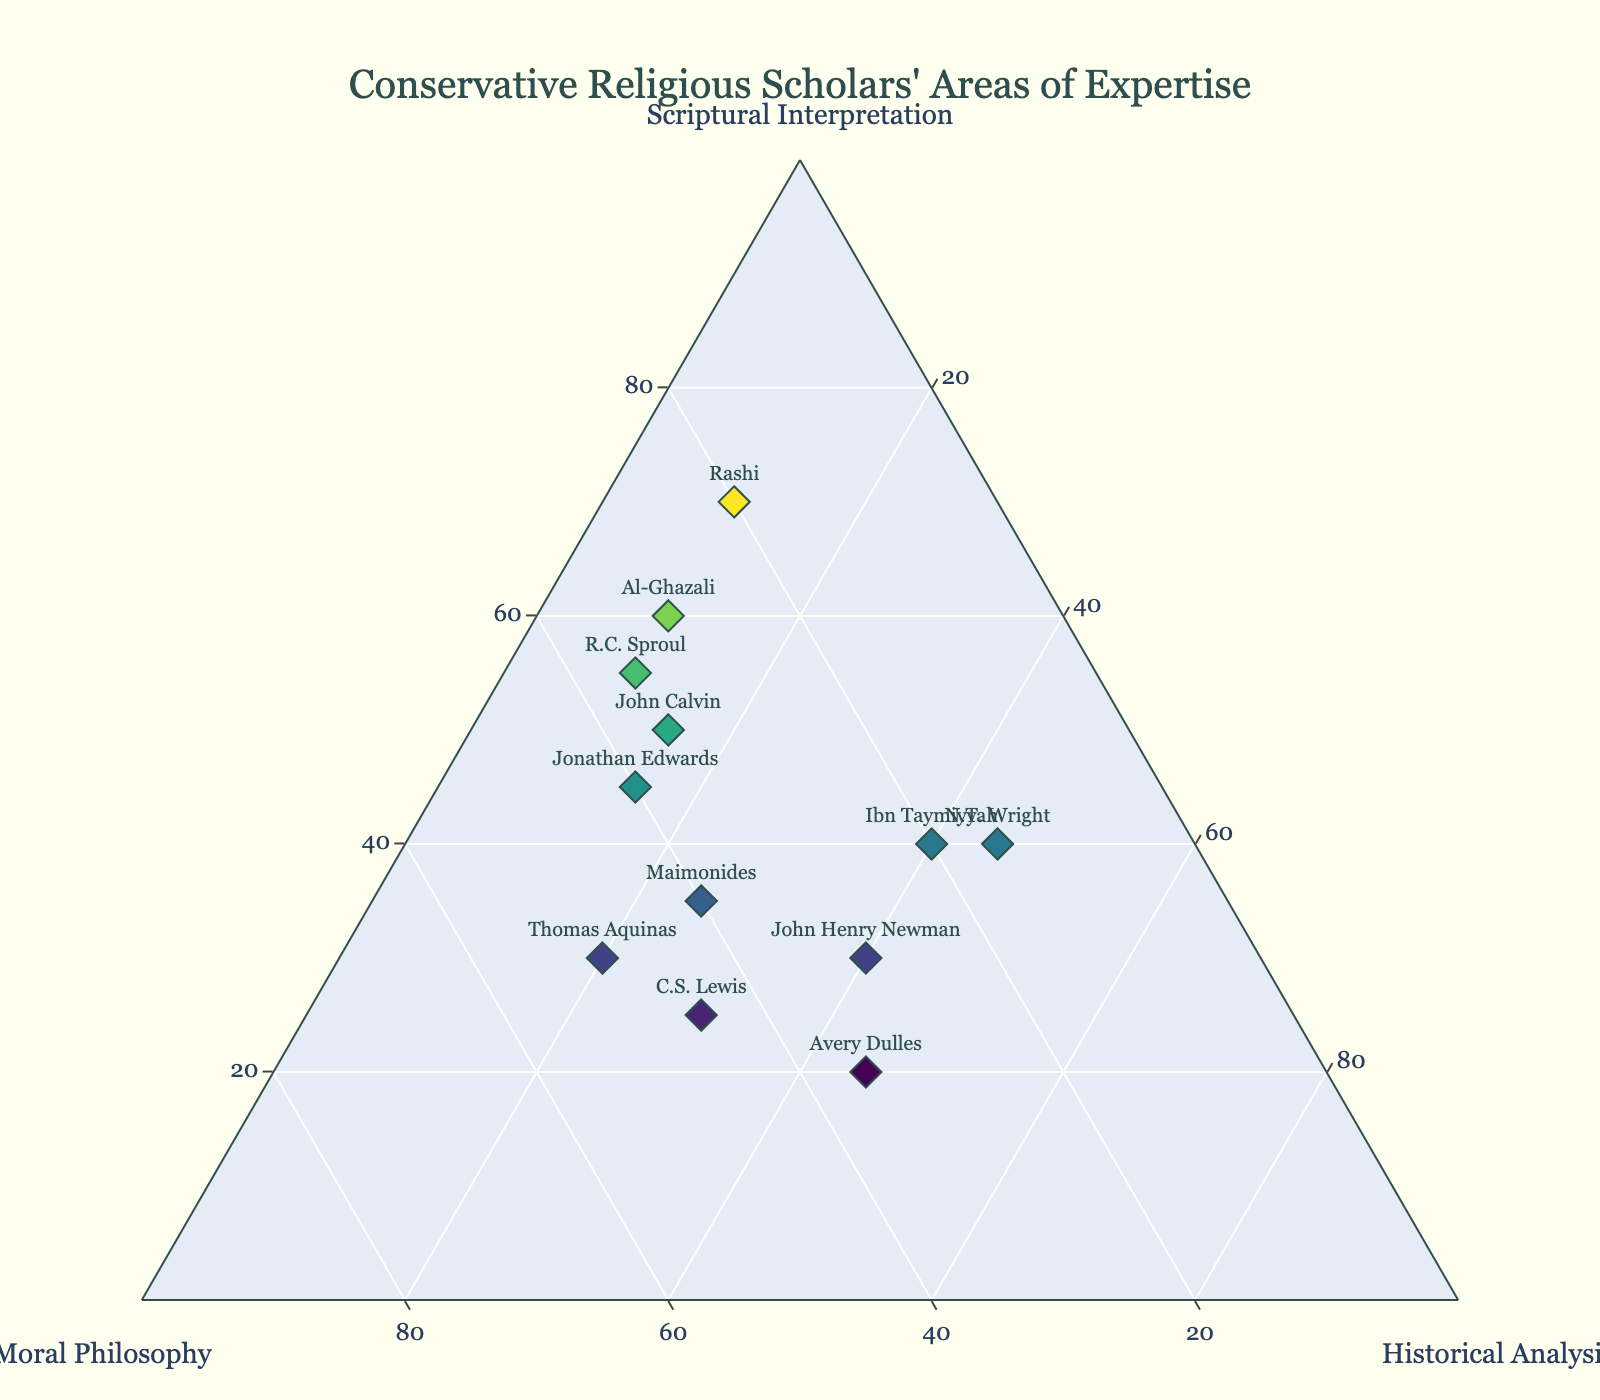What is the title of the ternary plot? The title of the ternary plot is placed at the top and usually describes the main subject visualized in the figure. Here, it particularly points out the theme of interest.
Answer: Conservative Religious Scholars' Areas of Expertise How many scholars are displayed in the ternary plot? Each scholar is represented by a single mark on the plot. Counting these marks will give the total number of scholars.
Answer: 12 Which scholar has the highest emphasis on Scriptural Interpretation? By looking at the axis labeled "Scriptural Interpretation," you can find the scholar whose marker is closest to this axis's apex. The percentage listed at this apex for the scholar can also be cross-referenced in the data.
Answer: Rashi Which scholars have an exactly equal focus on Scriptural Interpretation and Moral Philosophy? Look for markers whose values on Scriptural Interpretation and Moral Philosophy are the same or very close. The percentage values on the plot can identify this relationship.
Answer: John Henry Newman What is the combined focus on Historical Analysis for Thomas Aquinas and N.T. Wright? Sum up the percentages of Historical Analysis for both scholars using the data dictionary. Thomas Aquinas has 20%, and N.T. Wright has 45%. Thus, 20 + 45 = 65.
Answer: 65% Who has the lowest focus on Historical Analysis, and what is their emphasis on Scriptural Interpretation? Find the scholar with the smallest percentage in Historical Analysis and then locate their corresponding focus on Scriptural Interpretation. Avery Dulles has 45% Historical Analysis, but John Henry Newman has 40%. Both have a Scriptural Interpretation value respectively.
Answer: Rashi, 70% Which scholar exhibits the most balanced focus between all three areas of expertise? Find the scholar whose markers are approximately equidistant from the three apexes of the ternary plot, suggesting an equal distribution among Scriptural Interpretation, Moral Philosophy, and Historical Analysis.
Answer: Avery Dulles Who has an equal focus on Scriptural Interpretation and Historical Analysis but a different focus on Moral Philosophy? Look for overlap in the Scriptural Interpretation and Historical Analysis percentages and see if their percentage in Moral Philosophy differs. This might be visible directly on the plot.
Answer: John Henry Newman How many scholars have a higher focus on Moral Philosophy than any other domain? Count the scholars whose markers are closer to the apex of the axis titled "Moral Philosophy" as compared to others.
Answer: 3 